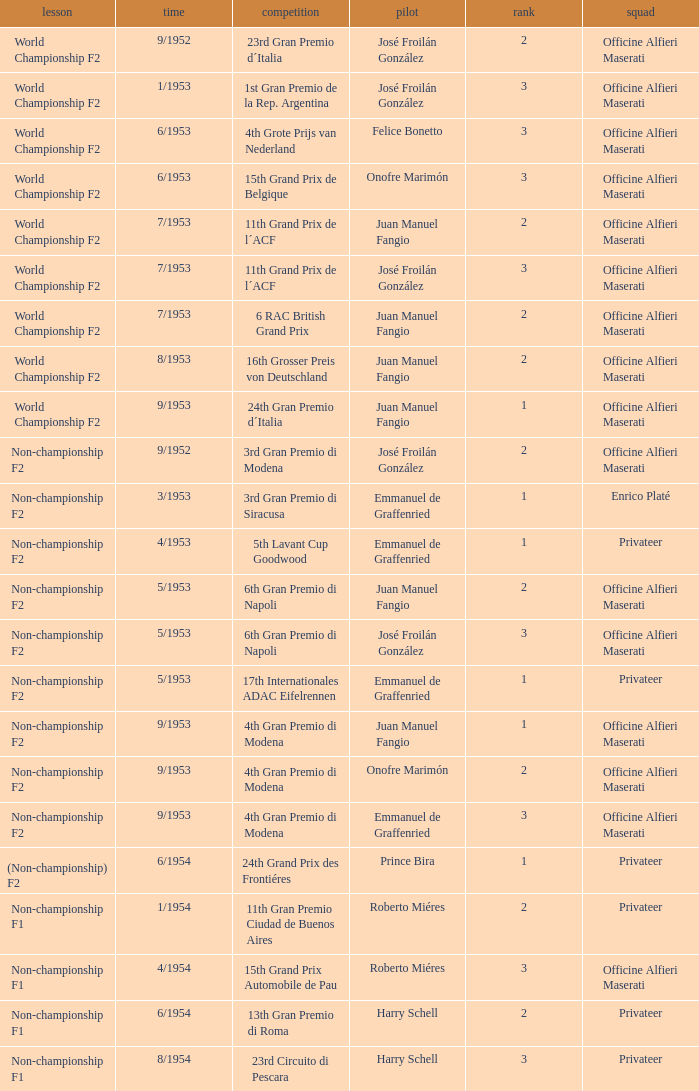What team has a drive name emmanuel de graffenried and a position larger than 1 as well as the date of 9/1953? Officine Alfieri Maserati. 